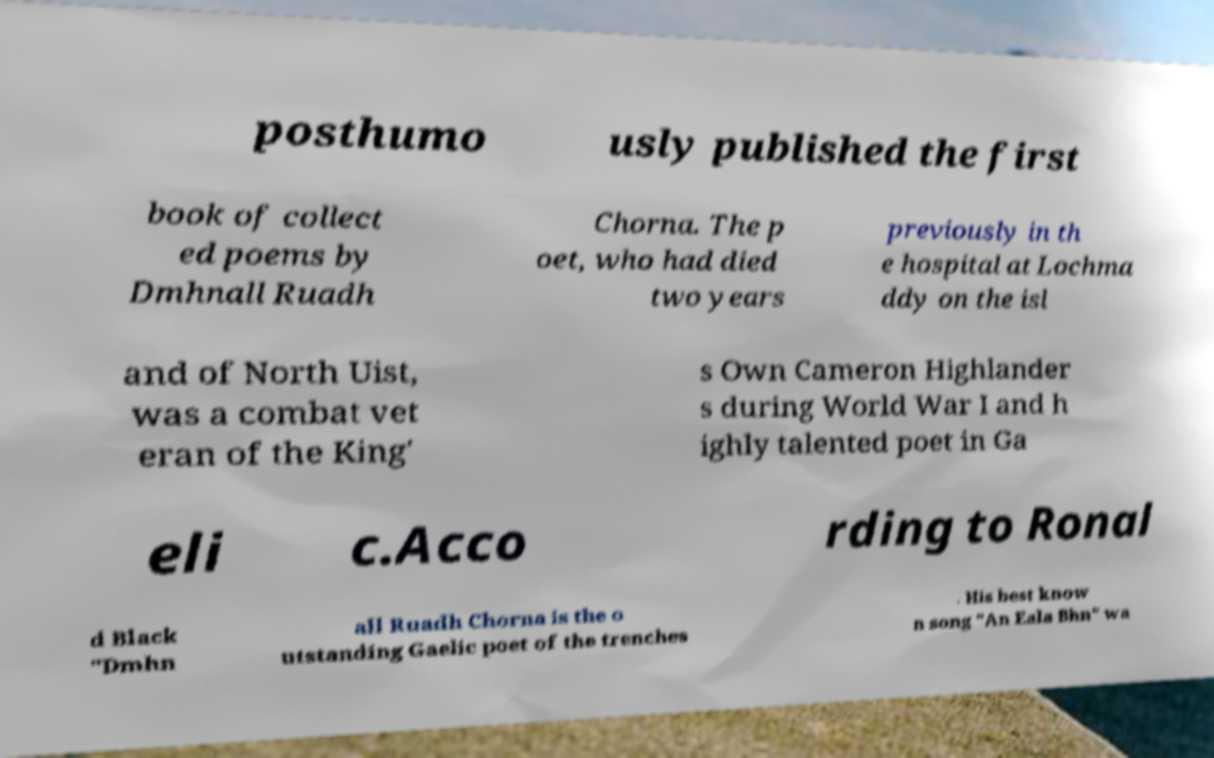Can you read and provide the text displayed in the image?This photo seems to have some interesting text. Can you extract and type it out for me? posthumo usly published the first book of collect ed poems by Dmhnall Ruadh Chorna. The p oet, who had died two years previously in th e hospital at Lochma ddy on the isl and of North Uist, was a combat vet eran of the King' s Own Cameron Highlander s during World War I and h ighly talented poet in Ga eli c.Acco rding to Ronal d Black "Dmhn all Ruadh Chorna is the o utstanding Gaelic poet of the trenches . His best know n song "An Eala Bhn" wa 